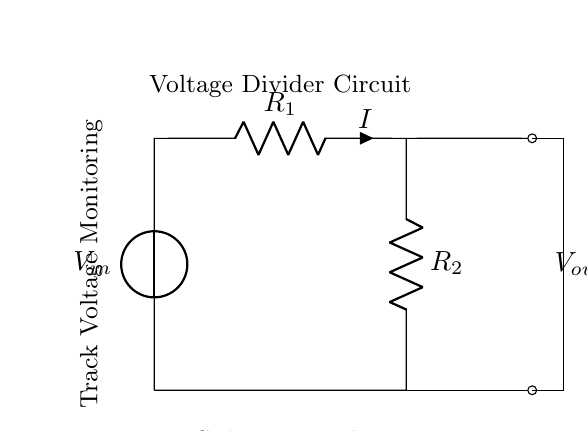What is the input voltage of the circuit? The input voltage, denoted as V_in, is the voltage provided by the source in the circuit. In the diagram, it is represented with the label near the voltage source.
Answer: V_in What are the values of the resistors in the voltage divider? The resistors in the circuit are labeled R_1 and R_2. To determine their values, one would look for any given numerical labels next to them in the context or circuit setup, which are not specified here.
Answer: R_1 and R_2 What does V_out represent in this circuit? V_out is the output voltage taken from the junction between the two resistors (R_1 and R_2). It is the voltage available for monitoring the track voltage.
Answer: Output voltage How is V_out calculated in a voltage divider? In a voltage divider, the output voltage V_out is calculated using the formula V_out = V_in * (R_2 / (R_1 + R_2)). This means it takes into account the ratio of R_2 to the total resistance of R_1 and R_2 combined. Understanding this ratio helps identify how much of the input voltage appears across R_2.
Answer: V_out = V_in * (R_2 / (R_1 + R_2)) What is the purpose of using a voltage divider in subway track monitoring? The purpose of the voltage divider in this context is to safely scale down the high track voltage to a level suitable for monitoring by measurement devices. This is crucial in ensuring that the monitoring equipment operates within safe voltage levels, preventing damage and ensuring accurate readings.
Answer: Safety and accuracy in monitoring What is the current I in this circuit? The current I in this circuit can be expressed in terms of the voltages and resistances using Ohm's law. Specifically, I can be calculated as I = V_in / (R_1 + R_2), indicating that the total current flowing through the circuit is dependent on the input voltage and the total resistance.
Answer: I = V_in / (R_1 + R_2) 